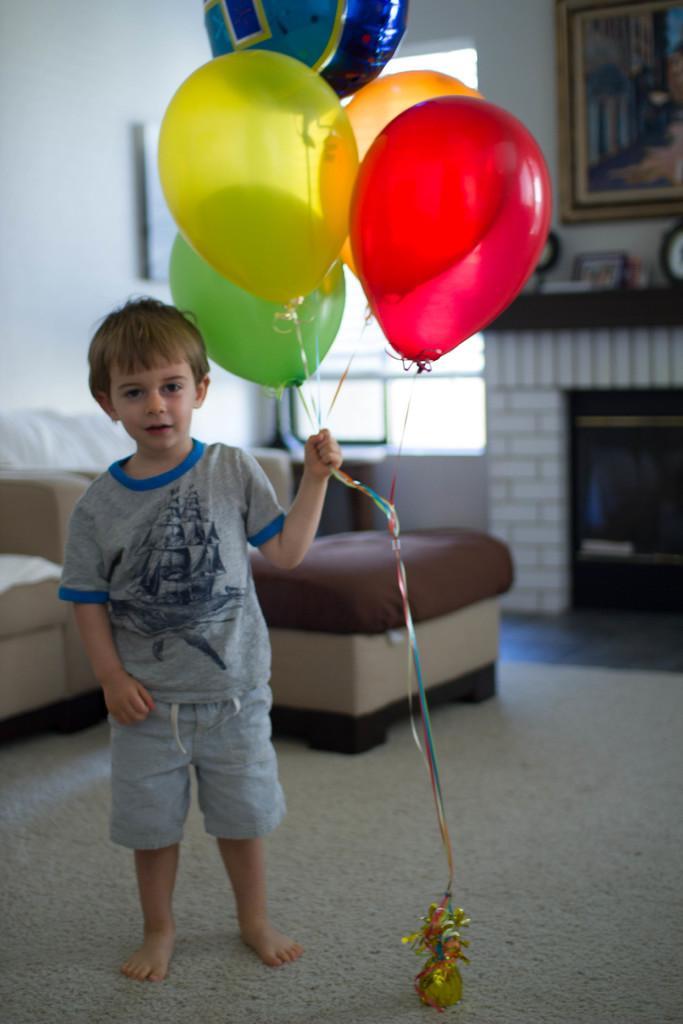In one or two sentences, can you explain what this image depicts? In the center of the image there is a boy standing on road and holding balloons. In the background we can see sofa, window, photo frame and wall. 